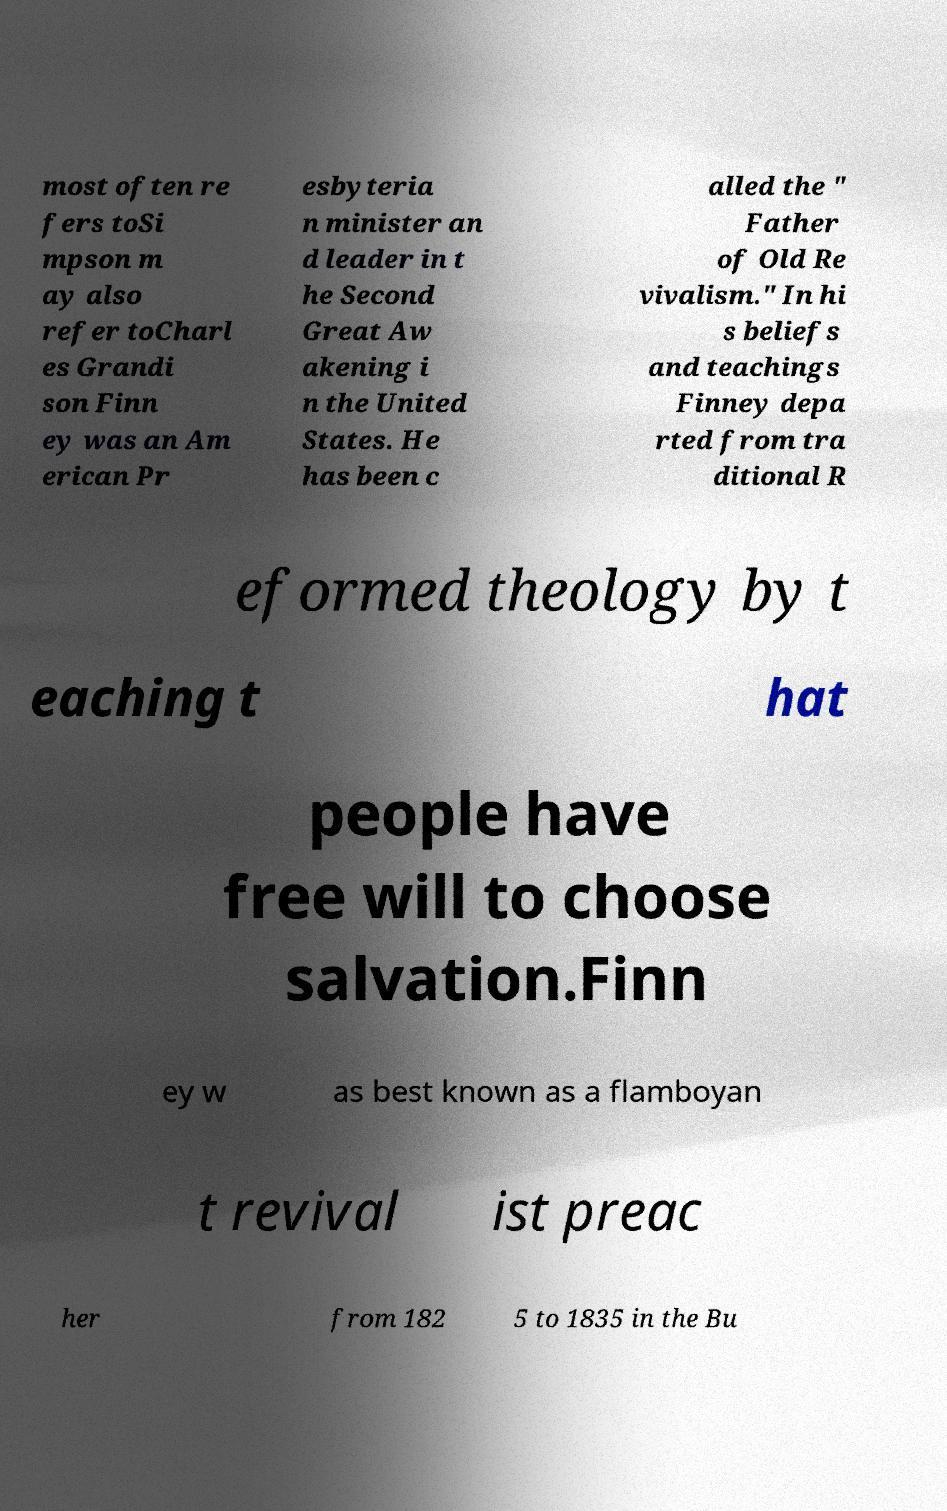I need the written content from this picture converted into text. Can you do that? most often re fers toSi mpson m ay also refer toCharl es Grandi son Finn ey was an Am erican Pr esbyteria n minister an d leader in t he Second Great Aw akening i n the United States. He has been c alled the " Father of Old Re vivalism." In hi s beliefs and teachings Finney depa rted from tra ditional R eformed theology by t eaching t hat people have free will to choose salvation.Finn ey w as best known as a flamboyan t revival ist preac her from 182 5 to 1835 in the Bu 